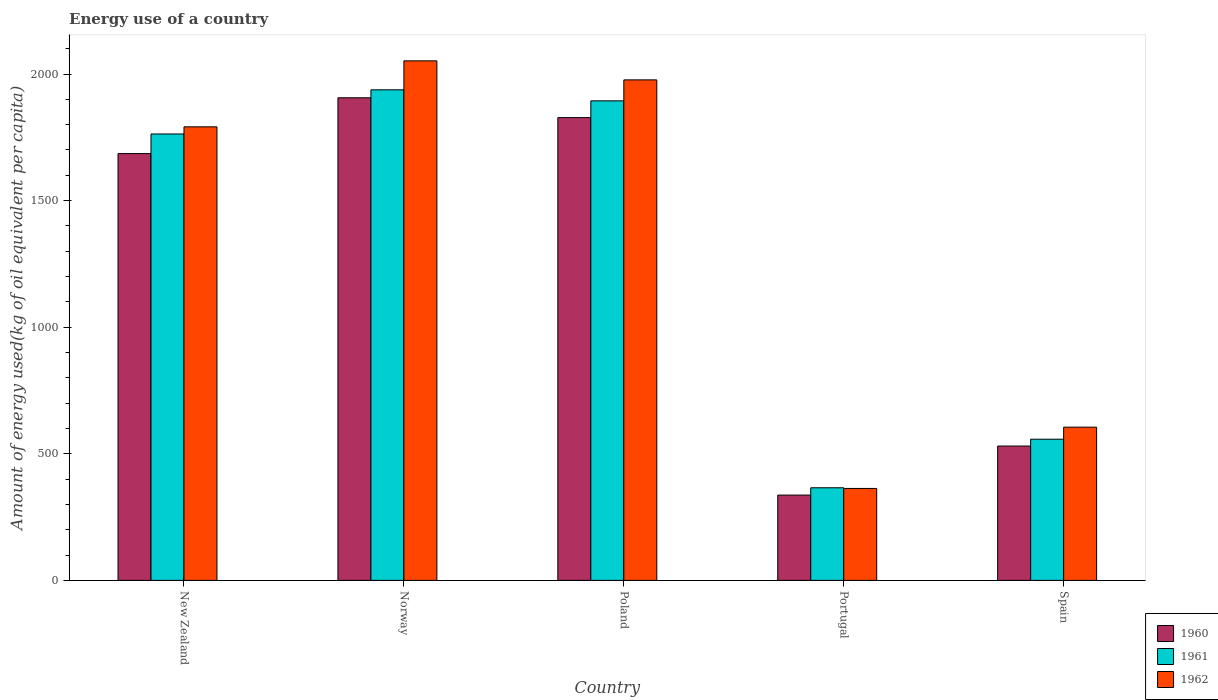Are the number of bars per tick equal to the number of legend labels?
Your answer should be very brief. Yes. How many bars are there on the 1st tick from the left?
Give a very brief answer. 3. How many bars are there on the 1st tick from the right?
Your response must be concise. 3. In how many cases, is the number of bars for a given country not equal to the number of legend labels?
Give a very brief answer. 0. What is the amount of energy used in in 1961 in Norway?
Ensure brevity in your answer.  1937.64. Across all countries, what is the maximum amount of energy used in in 1960?
Provide a succinct answer. 1906.17. Across all countries, what is the minimum amount of energy used in in 1962?
Make the answer very short. 363.16. In which country was the amount of energy used in in 1961 maximum?
Give a very brief answer. Norway. In which country was the amount of energy used in in 1960 minimum?
Ensure brevity in your answer.  Portugal. What is the total amount of energy used in in 1962 in the graph?
Make the answer very short. 6788.76. What is the difference between the amount of energy used in in 1961 in New Zealand and that in Poland?
Provide a short and direct response. -130.8. What is the difference between the amount of energy used in in 1962 in Spain and the amount of energy used in in 1960 in Norway?
Make the answer very short. -1300.95. What is the average amount of energy used in in 1962 per country?
Your answer should be compact. 1357.75. What is the difference between the amount of energy used in of/in 1960 and amount of energy used in of/in 1961 in Portugal?
Keep it short and to the point. -28.93. What is the ratio of the amount of energy used in in 1960 in New Zealand to that in Portugal?
Make the answer very short. 5. Is the difference between the amount of energy used in in 1960 in Poland and Portugal greater than the difference between the amount of energy used in in 1961 in Poland and Portugal?
Provide a succinct answer. No. What is the difference between the highest and the second highest amount of energy used in in 1962?
Give a very brief answer. -75.19. What is the difference between the highest and the lowest amount of energy used in in 1962?
Give a very brief answer. 1688.89. In how many countries, is the amount of energy used in in 1960 greater than the average amount of energy used in in 1960 taken over all countries?
Ensure brevity in your answer.  3. Is the sum of the amount of energy used in in 1960 in New Zealand and Norway greater than the maximum amount of energy used in in 1961 across all countries?
Offer a terse response. Yes. What does the 1st bar from the left in Poland represents?
Your response must be concise. 1960. Is it the case that in every country, the sum of the amount of energy used in in 1960 and amount of energy used in in 1962 is greater than the amount of energy used in in 1961?
Offer a very short reply. Yes. Are all the bars in the graph horizontal?
Offer a terse response. No. How many countries are there in the graph?
Keep it short and to the point. 5. What is the difference between two consecutive major ticks on the Y-axis?
Provide a short and direct response. 500. Where does the legend appear in the graph?
Your response must be concise. Bottom right. What is the title of the graph?
Offer a very short reply. Energy use of a country. Does "2009" appear as one of the legend labels in the graph?
Your answer should be very brief. No. What is the label or title of the Y-axis?
Your answer should be compact. Amount of energy used(kg of oil equivalent per capita). What is the Amount of energy used(kg of oil equivalent per capita) of 1960 in New Zealand?
Offer a terse response. 1685.79. What is the Amount of energy used(kg of oil equivalent per capita) in 1961 in New Zealand?
Keep it short and to the point. 1763.26. What is the Amount of energy used(kg of oil equivalent per capita) of 1962 in New Zealand?
Ensure brevity in your answer.  1791.46. What is the Amount of energy used(kg of oil equivalent per capita) of 1960 in Norway?
Your response must be concise. 1906.17. What is the Amount of energy used(kg of oil equivalent per capita) in 1961 in Norway?
Provide a succinct answer. 1937.64. What is the Amount of energy used(kg of oil equivalent per capita) in 1962 in Norway?
Keep it short and to the point. 2052.05. What is the Amount of energy used(kg of oil equivalent per capita) of 1960 in Poland?
Provide a short and direct response. 1827.94. What is the Amount of energy used(kg of oil equivalent per capita) of 1961 in Poland?
Give a very brief answer. 1894.06. What is the Amount of energy used(kg of oil equivalent per capita) of 1962 in Poland?
Provide a succinct answer. 1976.86. What is the Amount of energy used(kg of oil equivalent per capita) in 1960 in Portugal?
Provide a succinct answer. 336.91. What is the Amount of energy used(kg of oil equivalent per capita) in 1961 in Portugal?
Your response must be concise. 365.84. What is the Amount of energy used(kg of oil equivalent per capita) in 1962 in Portugal?
Give a very brief answer. 363.16. What is the Amount of energy used(kg of oil equivalent per capita) of 1960 in Spain?
Provide a succinct answer. 530.66. What is the Amount of energy used(kg of oil equivalent per capita) of 1961 in Spain?
Keep it short and to the point. 557.6. What is the Amount of energy used(kg of oil equivalent per capita) of 1962 in Spain?
Provide a short and direct response. 605.22. Across all countries, what is the maximum Amount of energy used(kg of oil equivalent per capita) of 1960?
Your response must be concise. 1906.17. Across all countries, what is the maximum Amount of energy used(kg of oil equivalent per capita) in 1961?
Offer a terse response. 1937.64. Across all countries, what is the maximum Amount of energy used(kg of oil equivalent per capita) in 1962?
Offer a terse response. 2052.05. Across all countries, what is the minimum Amount of energy used(kg of oil equivalent per capita) in 1960?
Provide a succinct answer. 336.91. Across all countries, what is the minimum Amount of energy used(kg of oil equivalent per capita) of 1961?
Your answer should be compact. 365.84. Across all countries, what is the minimum Amount of energy used(kg of oil equivalent per capita) in 1962?
Your answer should be very brief. 363.16. What is the total Amount of energy used(kg of oil equivalent per capita) in 1960 in the graph?
Your answer should be compact. 6287.48. What is the total Amount of energy used(kg of oil equivalent per capita) of 1961 in the graph?
Your answer should be compact. 6518.4. What is the total Amount of energy used(kg of oil equivalent per capita) in 1962 in the graph?
Offer a terse response. 6788.76. What is the difference between the Amount of energy used(kg of oil equivalent per capita) in 1960 in New Zealand and that in Norway?
Provide a short and direct response. -220.39. What is the difference between the Amount of energy used(kg of oil equivalent per capita) of 1961 in New Zealand and that in Norway?
Your answer should be very brief. -174.38. What is the difference between the Amount of energy used(kg of oil equivalent per capita) in 1962 in New Zealand and that in Norway?
Your answer should be compact. -260.59. What is the difference between the Amount of energy used(kg of oil equivalent per capita) in 1960 in New Zealand and that in Poland?
Provide a succinct answer. -142.15. What is the difference between the Amount of energy used(kg of oil equivalent per capita) in 1961 in New Zealand and that in Poland?
Keep it short and to the point. -130.8. What is the difference between the Amount of energy used(kg of oil equivalent per capita) of 1962 in New Zealand and that in Poland?
Provide a succinct answer. -185.4. What is the difference between the Amount of energy used(kg of oil equivalent per capita) of 1960 in New Zealand and that in Portugal?
Keep it short and to the point. 1348.87. What is the difference between the Amount of energy used(kg of oil equivalent per capita) in 1961 in New Zealand and that in Portugal?
Provide a succinct answer. 1397.42. What is the difference between the Amount of energy used(kg of oil equivalent per capita) of 1962 in New Zealand and that in Portugal?
Your answer should be very brief. 1428.3. What is the difference between the Amount of energy used(kg of oil equivalent per capita) in 1960 in New Zealand and that in Spain?
Ensure brevity in your answer.  1155.12. What is the difference between the Amount of energy used(kg of oil equivalent per capita) in 1961 in New Zealand and that in Spain?
Your answer should be very brief. 1205.66. What is the difference between the Amount of energy used(kg of oil equivalent per capita) in 1962 in New Zealand and that in Spain?
Give a very brief answer. 1186.24. What is the difference between the Amount of energy used(kg of oil equivalent per capita) of 1960 in Norway and that in Poland?
Keep it short and to the point. 78.24. What is the difference between the Amount of energy used(kg of oil equivalent per capita) in 1961 in Norway and that in Poland?
Your answer should be compact. 43.59. What is the difference between the Amount of energy used(kg of oil equivalent per capita) of 1962 in Norway and that in Poland?
Your response must be concise. 75.19. What is the difference between the Amount of energy used(kg of oil equivalent per capita) in 1960 in Norway and that in Portugal?
Your response must be concise. 1569.26. What is the difference between the Amount of energy used(kg of oil equivalent per capita) in 1961 in Norway and that in Portugal?
Provide a succinct answer. 1571.8. What is the difference between the Amount of energy used(kg of oil equivalent per capita) of 1962 in Norway and that in Portugal?
Provide a short and direct response. 1688.89. What is the difference between the Amount of energy used(kg of oil equivalent per capita) of 1960 in Norway and that in Spain?
Offer a very short reply. 1375.51. What is the difference between the Amount of energy used(kg of oil equivalent per capita) of 1961 in Norway and that in Spain?
Your answer should be compact. 1380.05. What is the difference between the Amount of energy used(kg of oil equivalent per capita) in 1962 in Norway and that in Spain?
Provide a short and direct response. 1446.83. What is the difference between the Amount of energy used(kg of oil equivalent per capita) of 1960 in Poland and that in Portugal?
Provide a succinct answer. 1491.02. What is the difference between the Amount of energy used(kg of oil equivalent per capita) in 1961 in Poland and that in Portugal?
Give a very brief answer. 1528.22. What is the difference between the Amount of energy used(kg of oil equivalent per capita) in 1962 in Poland and that in Portugal?
Keep it short and to the point. 1613.7. What is the difference between the Amount of energy used(kg of oil equivalent per capita) of 1960 in Poland and that in Spain?
Provide a succinct answer. 1297.27. What is the difference between the Amount of energy used(kg of oil equivalent per capita) in 1961 in Poland and that in Spain?
Provide a short and direct response. 1336.46. What is the difference between the Amount of energy used(kg of oil equivalent per capita) in 1962 in Poland and that in Spain?
Provide a succinct answer. 1371.64. What is the difference between the Amount of energy used(kg of oil equivalent per capita) in 1960 in Portugal and that in Spain?
Provide a succinct answer. -193.75. What is the difference between the Amount of energy used(kg of oil equivalent per capita) in 1961 in Portugal and that in Spain?
Provide a succinct answer. -191.76. What is the difference between the Amount of energy used(kg of oil equivalent per capita) of 1962 in Portugal and that in Spain?
Ensure brevity in your answer.  -242.06. What is the difference between the Amount of energy used(kg of oil equivalent per capita) in 1960 in New Zealand and the Amount of energy used(kg of oil equivalent per capita) in 1961 in Norway?
Make the answer very short. -251.86. What is the difference between the Amount of energy used(kg of oil equivalent per capita) of 1960 in New Zealand and the Amount of energy used(kg of oil equivalent per capita) of 1962 in Norway?
Offer a very short reply. -366.27. What is the difference between the Amount of energy used(kg of oil equivalent per capita) in 1961 in New Zealand and the Amount of energy used(kg of oil equivalent per capita) in 1962 in Norway?
Give a very brief answer. -288.79. What is the difference between the Amount of energy used(kg of oil equivalent per capita) of 1960 in New Zealand and the Amount of energy used(kg of oil equivalent per capita) of 1961 in Poland?
Provide a succinct answer. -208.27. What is the difference between the Amount of energy used(kg of oil equivalent per capita) in 1960 in New Zealand and the Amount of energy used(kg of oil equivalent per capita) in 1962 in Poland?
Your response must be concise. -291.07. What is the difference between the Amount of energy used(kg of oil equivalent per capita) of 1961 in New Zealand and the Amount of energy used(kg of oil equivalent per capita) of 1962 in Poland?
Keep it short and to the point. -213.6. What is the difference between the Amount of energy used(kg of oil equivalent per capita) of 1960 in New Zealand and the Amount of energy used(kg of oil equivalent per capita) of 1961 in Portugal?
Offer a very short reply. 1319.95. What is the difference between the Amount of energy used(kg of oil equivalent per capita) in 1960 in New Zealand and the Amount of energy used(kg of oil equivalent per capita) in 1962 in Portugal?
Provide a succinct answer. 1322.62. What is the difference between the Amount of energy used(kg of oil equivalent per capita) in 1961 in New Zealand and the Amount of energy used(kg of oil equivalent per capita) in 1962 in Portugal?
Ensure brevity in your answer.  1400.1. What is the difference between the Amount of energy used(kg of oil equivalent per capita) of 1960 in New Zealand and the Amount of energy used(kg of oil equivalent per capita) of 1961 in Spain?
Keep it short and to the point. 1128.19. What is the difference between the Amount of energy used(kg of oil equivalent per capita) in 1960 in New Zealand and the Amount of energy used(kg of oil equivalent per capita) in 1962 in Spain?
Make the answer very short. 1080.56. What is the difference between the Amount of energy used(kg of oil equivalent per capita) of 1961 in New Zealand and the Amount of energy used(kg of oil equivalent per capita) of 1962 in Spain?
Offer a very short reply. 1158.04. What is the difference between the Amount of energy used(kg of oil equivalent per capita) in 1960 in Norway and the Amount of energy used(kg of oil equivalent per capita) in 1961 in Poland?
Your response must be concise. 12.12. What is the difference between the Amount of energy used(kg of oil equivalent per capita) of 1960 in Norway and the Amount of energy used(kg of oil equivalent per capita) of 1962 in Poland?
Keep it short and to the point. -70.68. What is the difference between the Amount of energy used(kg of oil equivalent per capita) of 1961 in Norway and the Amount of energy used(kg of oil equivalent per capita) of 1962 in Poland?
Make the answer very short. -39.22. What is the difference between the Amount of energy used(kg of oil equivalent per capita) in 1960 in Norway and the Amount of energy used(kg of oil equivalent per capita) in 1961 in Portugal?
Your response must be concise. 1540.33. What is the difference between the Amount of energy used(kg of oil equivalent per capita) of 1960 in Norway and the Amount of energy used(kg of oil equivalent per capita) of 1962 in Portugal?
Your answer should be very brief. 1543.01. What is the difference between the Amount of energy used(kg of oil equivalent per capita) in 1961 in Norway and the Amount of energy used(kg of oil equivalent per capita) in 1962 in Portugal?
Provide a succinct answer. 1574.48. What is the difference between the Amount of energy used(kg of oil equivalent per capita) in 1960 in Norway and the Amount of energy used(kg of oil equivalent per capita) in 1961 in Spain?
Offer a very short reply. 1348.58. What is the difference between the Amount of energy used(kg of oil equivalent per capita) of 1960 in Norway and the Amount of energy used(kg of oil equivalent per capita) of 1962 in Spain?
Keep it short and to the point. 1300.95. What is the difference between the Amount of energy used(kg of oil equivalent per capita) in 1961 in Norway and the Amount of energy used(kg of oil equivalent per capita) in 1962 in Spain?
Your response must be concise. 1332.42. What is the difference between the Amount of energy used(kg of oil equivalent per capita) of 1960 in Poland and the Amount of energy used(kg of oil equivalent per capita) of 1961 in Portugal?
Your answer should be very brief. 1462.1. What is the difference between the Amount of energy used(kg of oil equivalent per capita) in 1960 in Poland and the Amount of energy used(kg of oil equivalent per capita) in 1962 in Portugal?
Offer a very short reply. 1464.77. What is the difference between the Amount of energy used(kg of oil equivalent per capita) of 1961 in Poland and the Amount of energy used(kg of oil equivalent per capita) of 1962 in Portugal?
Ensure brevity in your answer.  1530.89. What is the difference between the Amount of energy used(kg of oil equivalent per capita) of 1960 in Poland and the Amount of energy used(kg of oil equivalent per capita) of 1961 in Spain?
Make the answer very short. 1270.34. What is the difference between the Amount of energy used(kg of oil equivalent per capita) in 1960 in Poland and the Amount of energy used(kg of oil equivalent per capita) in 1962 in Spain?
Provide a short and direct response. 1222.71. What is the difference between the Amount of energy used(kg of oil equivalent per capita) in 1961 in Poland and the Amount of energy used(kg of oil equivalent per capita) in 1962 in Spain?
Offer a terse response. 1288.83. What is the difference between the Amount of energy used(kg of oil equivalent per capita) of 1960 in Portugal and the Amount of energy used(kg of oil equivalent per capita) of 1961 in Spain?
Keep it short and to the point. -220.69. What is the difference between the Amount of energy used(kg of oil equivalent per capita) in 1960 in Portugal and the Amount of energy used(kg of oil equivalent per capita) in 1962 in Spain?
Ensure brevity in your answer.  -268.31. What is the difference between the Amount of energy used(kg of oil equivalent per capita) in 1961 in Portugal and the Amount of energy used(kg of oil equivalent per capita) in 1962 in Spain?
Your answer should be very brief. -239.38. What is the average Amount of energy used(kg of oil equivalent per capita) in 1960 per country?
Keep it short and to the point. 1257.5. What is the average Amount of energy used(kg of oil equivalent per capita) of 1961 per country?
Your answer should be very brief. 1303.68. What is the average Amount of energy used(kg of oil equivalent per capita) in 1962 per country?
Your response must be concise. 1357.75. What is the difference between the Amount of energy used(kg of oil equivalent per capita) in 1960 and Amount of energy used(kg of oil equivalent per capita) in 1961 in New Zealand?
Your answer should be very brief. -77.47. What is the difference between the Amount of energy used(kg of oil equivalent per capita) in 1960 and Amount of energy used(kg of oil equivalent per capita) in 1962 in New Zealand?
Your answer should be compact. -105.67. What is the difference between the Amount of energy used(kg of oil equivalent per capita) in 1961 and Amount of energy used(kg of oil equivalent per capita) in 1962 in New Zealand?
Your answer should be very brief. -28.2. What is the difference between the Amount of energy used(kg of oil equivalent per capita) of 1960 and Amount of energy used(kg of oil equivalent per capita) of 1961 in Norway?
Give a very brief answer. -31.47. What is the difference between the Amount of energy used(kg of oil equivalent per capita) of 1960 and Amount of energy used(kg of oil equivalent per capita) of 1962 in Norway?
Make the answer very short. -145.88. What is the difference between the Amount of energy used(kg of oil equivalent per capita) of 1961 and Amount of energy used(kg of oil equivalent per capita) of 1962 in Norway?
Give a very brief answer. -114.41. What is the difference between the Amount of energy used(kg of oil equivalent per capita) of 1960 and Amount of energy used(kg of oil equivalent per capita) of 1961 in Poland?
Ensure brevity in your answer.  -66.12. What is the difference between the Amount of energy used(kg of oil equivalent per capita) of 1960 and Amount of energy used(kg of oil equivalent per capita) of 1962 in Poland?
Give a very brief answer. -148.92. What is the difference between the Amount of energy used(kg of oil equivalent per capita) in 1961 and Amount of energy used(kg of oil equivalent per capita) in 1962 in Poland?
Your answer should be compact. -82.8. What is the difference between the Amount of energy used(kg of oil equivalent per capita) of 1960 and Amount of energy used(kg of oil equivalent per capita) of 1961 in Portugal?
Keep it short and to the point. -28.93. What is the difference between the Amount of energy used(kg of oil equivalent per capita) of 1960 and Amount of energy used(kg of oil equivalent per capita) of 1962 in Portugal?
Your answer should be very brief. -26.25. What is the difference between the Amount of energy used(kg of oil equivalent per capita) in 1961 and Amount of energy used(kg of oil equivalent per capita) in 1962 in Portugal?
Your answer should be very brief. 2.68. What is the difference between the Amount of energy used(kg of oil equivalent per capita) in 1960 and Amount of energy used(kg of oil equivalent per capita) in 1961 in Spain?
Give a very brief answer. -26.93. What is the difference between the Amount of energy used(kg of oil equivalent per capita) in 1960 and Amount of energy used(kg of oil equivalent per capita) in 1962 in Spain?
Ensure brevity in your answer.  -74.56. What is the difference between the Amount of energy used(kg of oil equivalent per capita) of 1961 and Amount of energy used(kg of oil equivalent per capita) of 1962 in Spain?
Make the answer very short. -47.62. What is the ratio of the Amount of energy used(kg of oil equivalent per capita) in 1960 in New Zealand to that in Norway?
Your answer should be compact. 0.88. What is the ratio of the Amount of energy used(kg of oil equivalent per capita) in 1961 in New Zealand to that in Norway?
Your response must be concise. 0.91. What is the ratio of the Amount of energy used(kg of oil equivalent per capita) of 1962 in New Zealand to that in Norway?
Give a very brief answer. 0.87. What is the ratio of the Amount of energy used(kg of oil equivalent per capita) of 1960 in New Zealand to that in Poland?
Ensure brevity in your answer.  0.92. What is the ratio of the Amount of energy used(kg of oil equivalent per capita) in 1961 in New Zealand to that in Poland?
Ensure brevity in your answer.  0.93. What is the ratio of the Amount of energy used(kg of oil equivalent per capita) of 1962 in New Zealand to that in Poland?
Your answer should be very brief. 0.91. What is the ratio of the Amount of energy used(kg of oil equivalent per capita) in 1960 in New Zealand to that in Portugal?
Make the answer very short. 5. What is the ratio of the Amount of energy used(kg of oil equivalent per capita) of 1961 in New Zealand to that in Portugal?
Give a very brief answer. 4.82. What is the ratio of the Amount of energy used(kg of oil equivalent per capita) of 1962 in New Zealand to that in Portugal?
Ensure brevity in your answer.  4.93. What is the ratio of the Amount of energy used(kg of oil equivalent per capita) in 1960 in New Zealand to that in Spain?
Ensure brevity in your answer.  3.18. What is the ratio of the Amount of energy used(kg of oil equivalent per capita) of 1961 in New Zealand to that in Spain?
Offer a terse response. 3.16. What is the ratio of the Amount of energy used(kg of oil equivalent per capita) of 1962 in New Zealand to that in Spain?
Your answer should be compact. 2.96. What is the ratio of the Amount of energy used(kg of oil equivalent per capita) in 1960 in Norway to that in Poland?
Provide a short and direct response. 1.04. What is the ratio of the Amount of energy used(kg of oil equivalent per capita) of 1962 in Norway to that in Poland?
Offer a very short reply. 1.04. What is the ratio of the Amount of energy used(kg of oil equivalent per capita) of 1960 in Norway to that in Portugal?
Offer a very short reply. 5.66. What is the ratio of the Amount of energy used(kg of oil equivalent per capita) of 1961 in Norway to that in Portugal?
Ensure brevity in your answer.  5.3. What is the ratio of the Amount of energy used(kg of oil equivalent per capita) in 1962 in Norway to that in Portugal?
Your response must be concise. 5.65. What is the ratio of the Amount of energy used(kg of oil equivalent per capita) in 1960 in Norway to that in Spain?
Your answer should be very brief. 3.59. What is the ratio of the Amount of energy used(kg of oil equivalent per capita) in 1961 in Norway to that in Spain?
Your response must be concise. 3.48. What is the ratio of the Amount of energy used(kg of oil equivalent per capita) in 1962 in Norway to that in Spain?
Keep it short and to the point. 3.39. What is the ratio of the Amount of energy used(kg of oil equivalent per capita) of 1960 in Poland to that in Portugal?
Your answer should be compact. 5.43. What is the ratio of the Amount of energy used(kg of oil equivalent per capita) of 1961 in Poland to that in Portugal?
Give a very brief answer. 5.18. What is the ratio of the Amount of energy used(kg of oil equivalent per capita) in 1962 in Poland to that in Portugal?
Offer a terse response. 5.44. What is the ratio of the Amount of energy used(kg of oil equivalent per capita) of 1960 in Poland to that in Spain?
Your answer should be very brief. 3.44. What is the ratio of the Amount of energy used(kg of oil equivalent per capita) in 1961 in Poland to that in Spain?
Give a very brief answer. 3.4. What is the ratio of the Amount of energy used(kg of oil equivalent per capita) of 1962 in Poland to that in Spain?
Provide a short and direct response. 3.27. What is the ratio of the Amount of energy used(kg of oil equivalent per capita) of 1960 in Portugal to that in Spain?
Ensure brevity in your answer.  0.63. What is the ratio of the Amount of energy used(kg of oil equivalent per capita) of 1961 in Portugal to that in Spain?
Keep it short and to the point. 0.66. What is the ratio of the Amount of energy used(kg of oil equivalent per capita) of 1962 in Portugal to that in Spain?
Keep it short and to the point. 0.6. What is the difference between the highest and the second highest Amount of energy used(kg of oil equivalent per capita) in 1960?
Your answer should be compact. 78.24. What is the difference between the highest and the second highest Amount of energy used(kg of oil equivalent per capita) of 1961?
Make the answer very short. 43.59. What is the difference between the highest and the second highest Amount of energy used(kg of oil equivalent per capita) in 1962?
Offer a terse response. 75.19. What is the difference between the highest and the lowest Amount of energy used(kg of oil equivalent per capita) of 1960?
Ensure brevity in your answer.  1569.26. What is the difference between the highest and the lowest Amount of energy used(kg of oil equivalent per capita) of 1961?
Provide a short and direct response. 1571.8. What is the difference between the highest and the lowest Amount of energy used(kg of oil equivalent per capita) in 1962?
Offer a terse response. 1688.89. 